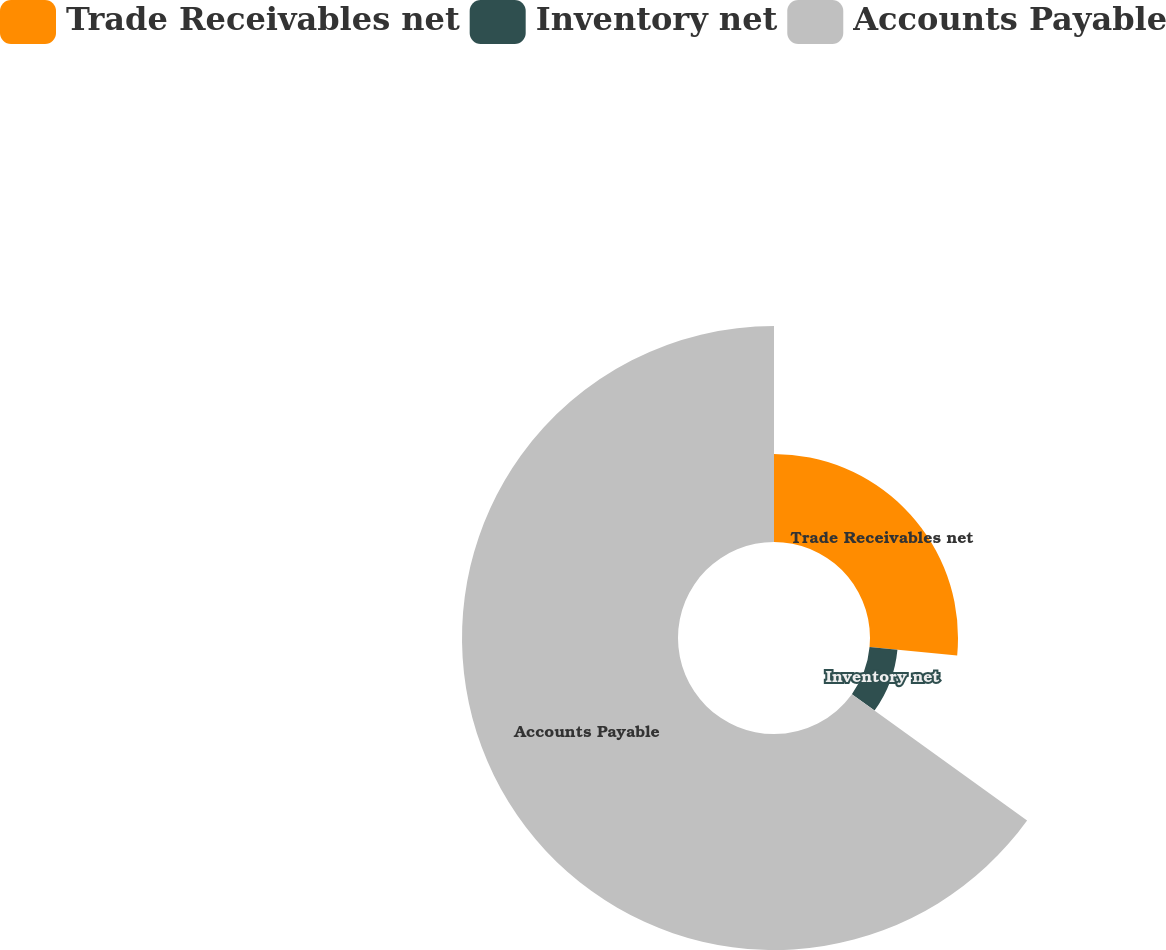<chart> <loc_0><loc_0><loc_500><loc_500><pie_chart><fcel>Trade Receivables net<fcel>Inventory net<fcel>Accounts Payable<nl><fcel>26.51%<fcel>8.43%<fcel>65.06%<nl></chart> 